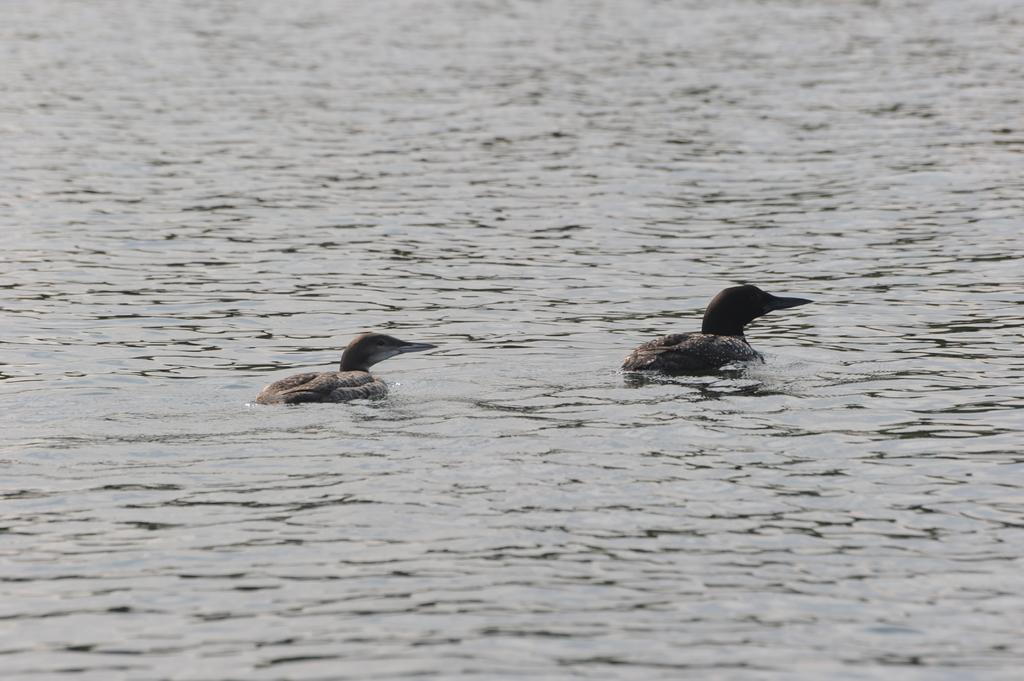How many ducks are in the image? There are two ducks in the image. What are the ducks doing in the image? The ducks are moving on the water. What is the primary element in which the ducks are situated? There is water visible in the image, and the ducks are moving on it. Can you describe the water in the image? The water appears to be flowing. What type of crime is being committed by the ducks in the image? There is no crime being committed by the ducks in the image; they are simply moving on the water. What kind of bait is being used by the ducks in the image? There is no bait present in the image, as it features two ducks moving on the water. 